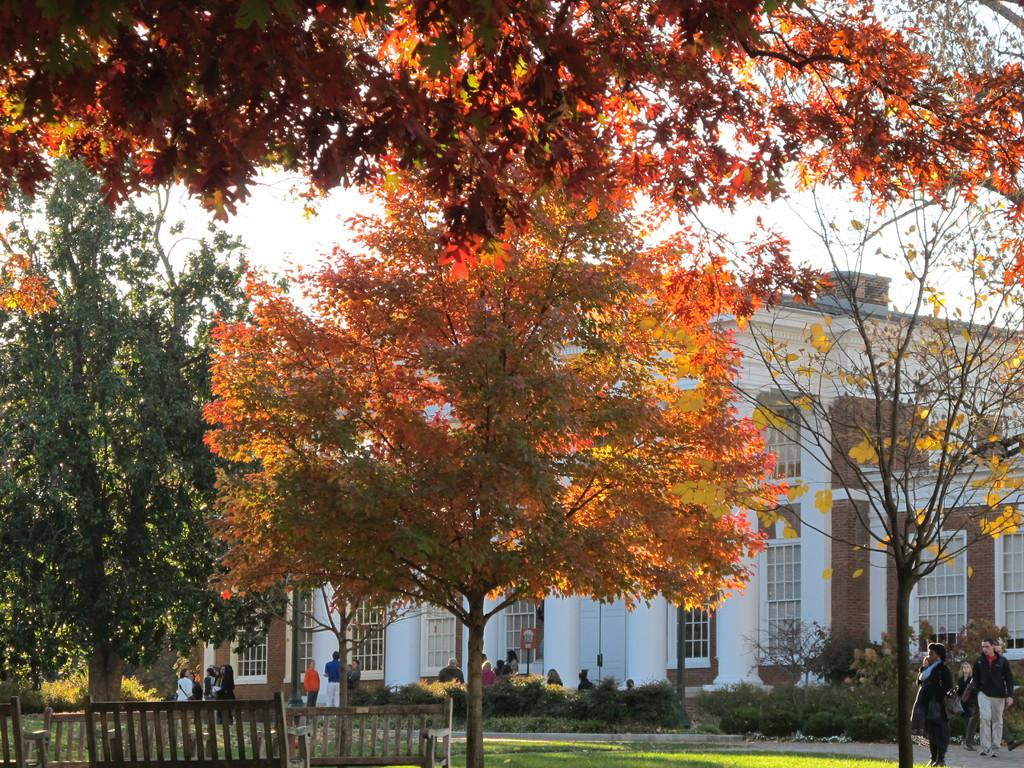What type of seating is visible in the image? There are benches in the image. What type of vegetation is present in the image? There is grass, plants, and trees in the image. Are there any structures visible in the image? Yes, there are buildings in the image. What is the condition of the sky in the image? The sky is visible at the top of the image. What type of drink is being served by the authority figure in the image? There is no authority figure or drink present in the image. What effect does the presence of the benches have on the people in the image? The presence of benches does not have a direct effect on the people in the image; they are simply seating options. 